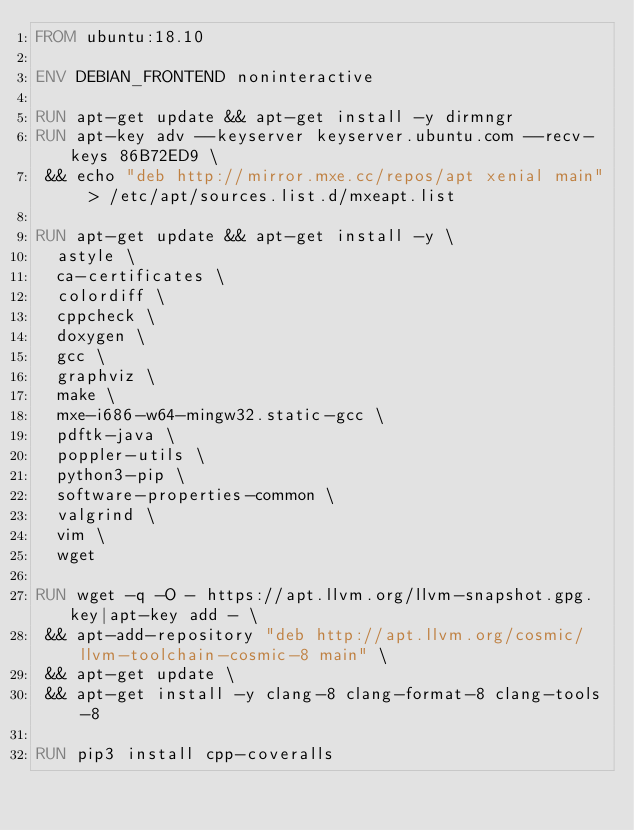<code> <loc_0><loc_0><loc_500><loc_500><_Dockerfile_>FROM ubuntu:18.10

ENV DEBIAN_FRONTEND noninteractive

RUN apt-get update && apt-get install -y dirmngr
RUN apt-key adv --keyserver keyserver.ubuntu.com --recv-keys 86B72ED9 \
 && echo "deb http://mirror.mxe.cc/repos/apt xenial main" > /etc/apt/sources.list.d/mxeapt.list

RUN apt-get update && apt-get install -y \
	astyle \
	ca-certificates \
	colordiff \
	cppcheck \
	doxygen \
	gcc \
	graphviz \
	make \
	mxe-i686-w64-mingw32.static-gcc \
	pdftk-java \
	poppler-utils \
	python3-pip \
	software-properties-common \
	valgrind \
	vim \
	wget

RUN wget -q -O - https://apt.llvm.org/llvm-snapshot.gpg.key|apt-key add - \
 && apt-add-repository "deb http://apt.llvm.org/cosmic/ llvm-toolchain-cosmic-8 main" \
 && apt-get update \
 && apt-get install -y clang-8 clang-format-8 clang-tools-8

RUN pip3 install cpp-coveralls
</code> 